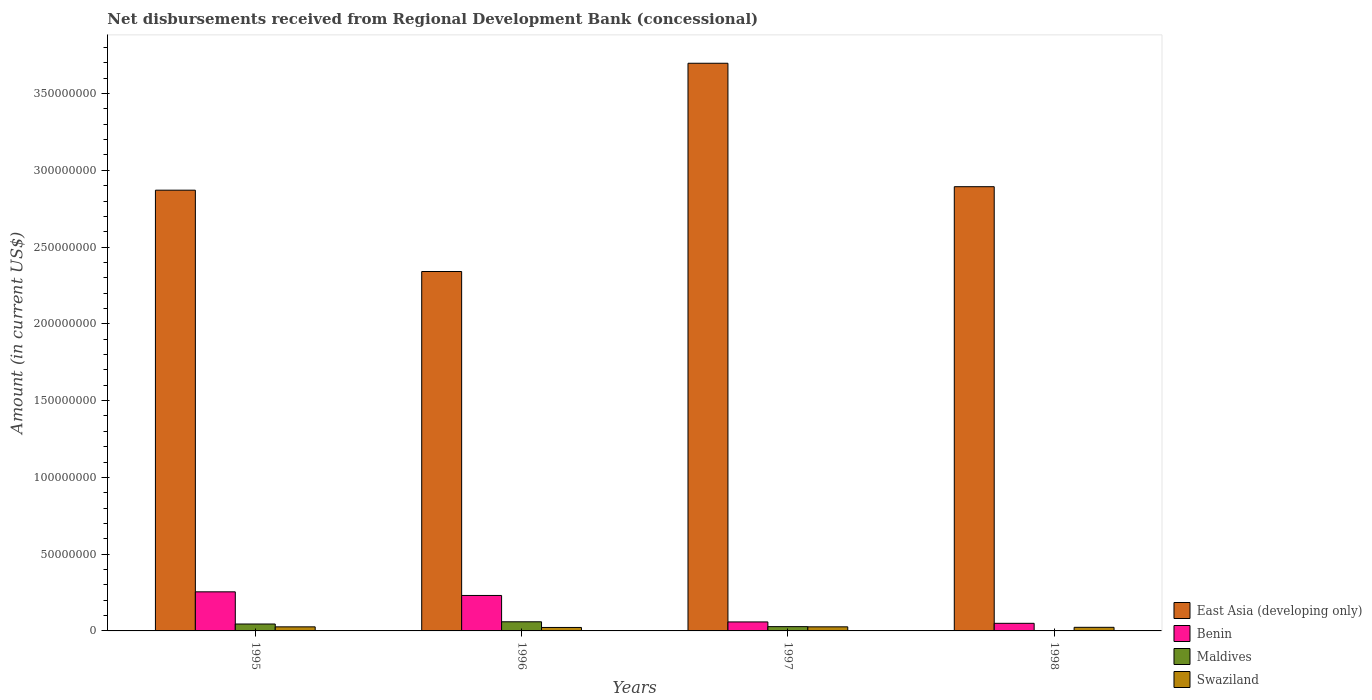How many different coloured bars are there?
Provide a succinct answer. 4. Are the number of bars on each tick of the X-axis equal?
Keep it short and to the point. Yes. How many bars are there on the 2nd tick from the left?
Your response must be concise. 4. How many bars are there on the 4th tick from the right?
Keep it short and to the point. 4. In how many cases, is the number of bars for a given year not equal to the number of legend labels?
Give a very brief answer. 0. What is the amount of disbursements received from Regional Development Bank in Swaziland in 1997?
Provide a succinct answer. 2.66e+06. Across all years, what is the maximum amount of disbursements received from Regional Development Bank in Swaziland?
Provide a succinct answer. 2.66e+06. Across all years, what is the minimum amount of disbursements received from Regional Development Bank in Swaziland?
Offer a very short reply. 2.25e+06. In which year was the amount of disbursements received from Regional Development Bank in East Asia (developing only) maximum?
Give a very brief answer. 1997. What is the total amount of disbursements received from Regional Development Bank in Maldives in the graph?
Make the answer very short. 1.35e+07. What is the difference between the amount of disbursements received from Regional Development Bank in Benin in 1995 and that in 1996?
Your response must be concise. 2.36e+06. What is the difference between the amount of disbursements received from Regional Development Bank in Benin in 1996 and the amount of disbursements received from Regional Development Bank in Swaziland in 1995?
Keep it short and to the point. 2.04e+07. What is the average amount of disbursements received from Regional Development Bank in Maldives per year?
Make the answer very short. 3.37e+06. In the year 1997, what is the difference between the amount of disbursements received from Regional Development Bank in Swaziland and amount of disbursements received from Regional Development Bank in Maldives?
Your answer should be compact. -1.33e+05. What is the ratio of the amount of disbursements received from Regional Development Bank in Swaziland in 1995 to that in 1996?
Offer a very short reply. 1.18. Is the amount of disbursements received from Regional Development Bank in Maldives in 1996 less than that in 1997?
Ensure brevity in your answer.  No. Is the difference between the amount of disbursements received from Regional Development Bank in Swaziland in 1996 and 1997 greater than the difference between the amount of disbursements received from Regional Development Bank in Maldives in 1996 and 1997?
Your answer should be very brief. No. What is the difference between the highest and the second highest amount of disbursements received from Regional Development Bank in Benin?
Provide a succinct answer. 2.36e+06. What is the difference between the highest and the lowest amount of disbursements received from Regional Development Bank in Benin?
Provide a succinct answer. 2.05e+07. In how many years, is the amount of disbursements received from Regional Development Bank in Benin greater than the average amount of disbursements received from Regional Development Bank in Benin taken over all years?
Offer a terse response. 2. Is it the case that in every year, the sum of the amount of disbursements received from Regional Development Bank in Maldives and amount of disbursements received from Regional Development Bank in East Asia (developing only) is greater than the sum of amount of disbursements received from Regional Development Bank in Swaziland and amount of disbursements received from Regional Development Bank in Benin?
Provide a succinct answer. Yes. What does the 2nd bar from the left in 1996 represents?
Offer a very short reply. Benin. What does the 3rd bar from the right in 1997 represents?
Provide a succinct answer. Benin. How many years are there in the graph?
Ensure brevity in your answer.  4. What is the difference between two consecutive major ticks on the Y-axis?
Offer a terse response. 5.00e+07. Are the values on the major ticks of Y-axis written in scientific E-notation?
Offer a terse response. No. Does the graph contain grids?
Give a very brief answer. No. What is the title of the graph?
Provide a succinct answer. Net disbursements received from Regional Development Bank (concessional). What is the Amount (in current US$) of East Asia (developing only) in 1995?
Your answer should be compact. 2.87e+08. What is the Amount (in current US$) of Benin in 1995?
Ensure brevity in your answer.  2.55e+07. What is the Amount (in current US$) in Maldives in 1995?
Ensure brevity in your answer.  4.51e+06. What is the Amount (in current US$) in Swaziland in 1995?
Offer a terse response. 2.65e+06. What is the Amount (in current US$) of East Asia (developing only) in 1996?
Provide a succinct answer. 2.34e+08. What is the Amount (in current US$) of Benin in 1996?
Provide a succinct answer. 2.31e+07. What is the Amount (in current US$) of Maldives in 1996?
Your answer should be very brief. 5.95e+06. What is the Amount (in current US$) in Swaziland in 1996?
Your response must be concise. 2.25e+06. What is the Amount (in current US$) in East Asia (developing only) in 1997?
Make the answer very short. 3.70e+08. What is the Amount (in current US$) of Benin in 1997?
Your answer should be compact. 5.86e+06. What is the Amount (in current US$) in Maldives in 1997?
Your answer should be compact. 2.80e+06. What is the Amount (in current US$) of Swaziland in 1997?
Offer a very short reply. 2.66e+06. What is the Amount (in current US$) of East Asia (developing only) in 1998?
Offer a terse response. 2.89e+08. What is the Amount (in current US$) in Benin in 1998?
Make the answer very short. 4.96e+06. What is the Amount (in current US$) of Maldives in 1998?
Your answer should be compact. 2.22e+05. What is the Amount (in current US$) of Swaziland in 1998?
Provide a succinct answer. 2.34e+06. Across all years, what is the maximum Amount (in current US$) in East Asia (developing only)?
Ensure brevity in your answer.  3.70e+08. Across all years, what is the maximum Amount (in current US$) in Benin?
Provide a succinct answer. 2.55e+07. Across all years, what is the maximum Amount (in current US$) in Maldives?
Provide a succinct answer. 5.95e+06. Across all years, what is the maximum Amount (in current US$) of Swaziland?
Offer a very short reply. 2.66e+06. Across all years, what is the minimum Amount (in current US$) of East Asia (developing only)?
Keep it short and to the point. 2.34e+08. Across all years, what is the minimum Amount (in current US$) in Benin?
Provide a succinct answer. 4.96e+06. Across all years, what is the minimum Amount (in current US$) of Maldives?
Offer a very short reply. 2.22e+05. Across all years, what is the minimum Amount (in current US$) of Swaziland?
Ensure brevity in your answer.  2.25e+06. What is the total Amount (in current US$) of East Asia (developing only) in the graph?
Make the answer very short. 1.18e+09. What is the total Amount (in current US$) in Benin in the graph?
Offer a very short reply. 5.94e+07. What is the total Amount (in current US$) in Maldives in the graph?
Your answer should be very brief. 1.35e+07. What is the total Amount (in current US$) in Swaziland in the graph?
Offer a very short reply. 9.91e+06. What is the difference between the Amount (in current US$) in East Asia (developing only) in 1995 and that in 1996?
Ensure brevity in your answer.  5.30e+07. What is the difference between the Amount (in current US$) in Benin in 1995 and that in 1996?
Make the answer very short. 2.36e+06. What is the difference between the Amount (in current US$) in Maldives in 1995 and that in 1996?
Your response must be concise. -1.44e+06. What is the difference between the Amount (in current US$) of Swaziland in 1995 and that in 1996?
Give a very brief answer. 3.98e+05. What is the difference between the Amount (in current US$) of East Asia (developing only) in 1995 and that in 1997?
Provide a short and direct response. -8.27e+07. What is the difference between the Amount (in current US$) in Benin in 1995 and that in 1997?
Offer a terse response. 1.96e+07. What is the difference between the Amount (in current US$) in Maldives in 1995 and that in 1997?
Provide a succinct answer. 1.71e+06. What is the difference between the Amount (in current US$) in Swaziland in 1995 and that in 1997?
Offer a very short reply. -1.20e+04. What is the difference between the Amount (in current US$) of East Asia (developing only) in 1995 and that in 1998?
Make the answer very short. -2.27e+06. What is the difference between the Amount (in current US$) in Benin in 1995 and that in 1998?
Your response must be concise. 2.05e+07. What is the difference between the Amount (in current US$) in Maldives in 1995 and that in 1998?
Ensure brevity in your answer.  4.29e+06. What is the difference between the Amount (in current US$) in Swaziland in 1995 and that in 1998?
Provide a short and direct response. 3.06e+05. What is the difference between the Amount (in current US$) in East Asia (developing only) in 1996 and that in 1997?
Provide a succinct answer. -1.36e+08. What is the difference between the Amount (in current US$) in Benin in 1996 and that in 1997?
Make the answer very short. 1.72e+07. What is the difference between the Amount (in current US$) in Maldives in 1996 and that in 1997?
Give a very brief answer. 3.15e+06. What is the difference between the Amount (in current US$) in Swaziland in 1996 and that in 1997?
Provide a succinct answer. -4.10e+05. What is the difference between the Amount (in current US$) in East Asia (developing only) in 1996 and that in 1998?
Offer a terse response. -5.53e+07. What is the difference between the Amount (in current US$) in Benin in 1996 and that in 1998?
Provide a short and direct response. 1.81e+07. What is the difference between the Amount (in current US$) of Maldives in 1996 and that in 1998?
Your response must be concise. 5.73e+06. What is the difference between the Amount (in current US$) of Swaziland in 1996 and that in 1998?
Offer a terse response. -9.20e+04. What is the difference between the Amount (in current US$) of East Asia (developing only) in 1997 and that in 1998?
Provide a succinct answer. 8.04e+07. What is the difference between the Amount (in current US$) of Benin in 1997 and that in 1998?
Provide a short and direct response. 9.02e+05. What is the difference between the Amount (in current US$) of Maldives in 1997 and that in 1998?
Provide a succinct answer. 2.57e+06. What is the difference between the Amount (in current US$) of Swaziland in 1997 and that in 1998?
Your answer should be compact. 3.18e+05. What is the difference between the Amount (in current US$) in East Asia (developing only) in 1995 and the Amount (in current US$) in Benin in 1996?
Your answer should be compact. 2.64e+08. What is the difference between the Amount (in current US$) in East Asia (developing only) in 1995 and the Amount (in current US$) in Maldives in 1996?
Your answer should be very brief. 2.81e+08. What is the difference between the Amount (in current US$) of East Asia (developing only) in 1995 and the Amount (in current US$) of Swaziland in 1996?
Provide a short and direct response. 2.85e+08. What is the difference between the Amount (in current US$) of Benin in 1995 and the Amount (in current US$) of Maldives in 1996?
Keep it short and to the point. 1.95e+07. What is the difference between the Amount (in current US$) in Benin in 1995 and the Amount (in current US$) in Swaziland in 1996?
Keep it short and to the point. 2.32e+07. What is the difference between the Amount (in current US$) of Maldives in 1995 and the Amount (in current US$) of Swaziland in 1996?
Your answer should be compact. 2.26e+06. What is the difference between the Amount (in current US$) of East Asia (developing only) in 1995 and the Amount (in current US$) of Benin in 1997?
Keep it short and to the point. 2.81e+08. What is the difference between the Amount (in current US$) in East Asia (developing only) in 1995 and the Amount (in current US$) in Maldives in 1997?
Your response must be concise. 2.84e+08. What is the difference between the Amount (in current US$) of East Asia (developing only) in 1995 and the Amount (in current US$) of Swaziland in 1997?
Give a very brief answer. 2.84e+08. What is the difference between the Amount (in current US$) in Benin in 1995 and the Amount (in current US$) in Maldives in 1997?
Your response must be concise. 2.27e+07. What is the difference between the Amount (in current US$) in Benin in 1995 and the Amount (in current US$) in Swaziland in 1997?
Offer a very short reply. 2.28e+07. What is the difference between the Amount (in current US$) in Maldives in 1995 and the Amount (in current US$) in Swaziland in 1997?
Make the answer very short. 1.85e+06. What is the difference between the Amount (in current US$) in East Asia (developing only) in 1995 and the Amount (in current US$) in Benin in 1998?
Offer a very short reply. 2.82e+08. What is the difference between the Amount (in current US$) in East Asia (developing only) in 1995 and the Amount (in current US$) in Maldives in 1998?
Provide a short and direct response. 2.87e+08. What is the difference between the Amount (in current US$) in East Asia (developing only) in 1995 and the Amount (in current US$) in Swaziland in 1998?
Provide a succinct answer. 2.85e+08. What is the difference between the Amount (in current US$) of Benin in 1995 and the Amount (in current US$) of Maldives in 1998?
Your answer should be compact. 2.52e+07. What is the difference between the Amount (in current US$) of Benin in 1995 and the Amount (in current US$) of Swaziland in 1998?
Ensure brevity in your answer.  2.31e+07. What is the difference between the Amount (in current US$) in Maldives in 1995 and the Amount (in current US$) in Swaziland in 1998?
Make the answer very short. 2.16e+06. What is the difference between the Amount (in current US$) in East Asia (developing only) in 1996 and the Amount (in current US$) in Benin in 1997?
Ensure brevity in your answer.  2.28e+08. What is the difference between the Amount (in current US$) in East Asia (developing only) in 1996 and the Amount (in current US$) in Maldives in 1997?
Your answer should be compact. 2.31e+08. What is the difference between the Amount (in current US$) in East Asia (developing only) in 1996 and the Amount (in current US$) in Swaziland in 1997?
Give a very brief answer. 2.31e+08. What is the difference between the Amount (in current US$) of Benin in 1996 and the Amount (in current US$) of Maldives in 1997?
Provide a succinct answer. 2.03e+07. What is the difference between the Amount (in current US$) in Benin in 1996 and the Amount (in current US$) in Swaziland in 1997?
Your answer should be very brief. 2.04e+07. What is the difference between the Amount (in current US$) of Maldives in 1996 and the Amount (in current US$) of Swaziland in 1997?
Offer a very short reply. 3.29e+06. What is the difference between the Amount (in current US$) in East Asia (developing only) in 1996 and the Amount (in current US$) in Benin in 1998?
Provide a succinct answer. 2.29e+08. What is the difference between the Amount (in current US$) of East Asia (developing only) in 1996 and the Amount (in current US$) of Maldives in 1998?
Offer a terse response. 2.34e+08. What is the difference between the Amount (in current US$) in East Asia (developing only) in 1996 and the Amount (in current US$) in Swaziland in 1998?
Keep it short and to the point. 2.32e+08. What is the difference between the Amount (in current US$) of Benin in 1996 and the Amount (in current US$) of Maldives in 1998?
Ensure brevity in your answer.  2.29e+07. What is the difference between the Amount (in current US$) in Benin in 1996 and the Amount (in current US$) in Swaziland in 1998?
Offer a terse response. 2.08e+07. What is the difference between the Amount (in current US$) of Maldives in 1996 and the Amount (in current US$) of Swaziland in 1998?
Give a very brief answer. 3.60e+06. What is the difference between the Amount (in current US$) in East Asia (developing only) in 1997 and the Amount (in current US$) in Benin in 1998?
Make the answer very short. 3.65e+08. What is the difference between the Amount (in current US$) of East Asia (developing only) in 1997 and the Amount (in current US$) of Maldives in 1998?
Provide a succinct answer. 3.70e+08. What is the difference between the Amount (in current US$) of East Asia (developing only) in 1997 and the Amount (in current US$) of Swaziland in 1998?
Keep it short and to the point. 3.67e+08. What is the difference between the Amount (in current US$) in Benin in 1997 and the Amount (in current US$) in Maldives in 1998?
Offer a very short reply. 5.64e+06. What is the difference between the Amount (in current US$) of Benin in 1997 and the Amount (in current US$) of Swaziland in 1998?
Your answer should be very brief. 3.51e+06. What is the difference between the Amount (in current US$) of Maldives in 1997 and the Amount (in current US$) of Swaziland in 1998?
Your response must be concise. 4.51e+05. What is the average Amount (in current US$) of East Asia (developing only) per year?
Provide a short and direct response. 2.95e+08. What is the average Amount (in current US$) of Benin per year?
Offer a very short reply. 1.48e+07. What is the average Amount (in current US$) of Maldives per year?
Make the answer very short. 3.37e+06. What is the average Amount (in current US$) in Swaziland per year?
Keep it short and to the point. 2.48e+06. In the year 1995, what is the difference between the Amount (in current US$) in East Asia (developing only) and Amount (in current US$) in Benin?
Ensure brevity in your answer.  2.62e+08. In the year 1995, what is the difference between the Amount (in current US$) in East Asia (developing only) and Amount (in current US$) in Maldives?
Your answer should be very brief. 2.83e+08. In the year 1995, what is the difference between the Amount (in current US$) in East Asia (developing only) and Amount (in current US$) in Swaziland?
Your answer should be compact. 2.84e+08. In the year 1995, what is the difference between the Amount (in current US$) of Benin and Amount (in current US$) of Maldives?
Provide a short and direct response. 2.09e+07. In the year 1995, what is the difference between the Amount (in current US$) of Benin and Amount (in current US$) of Swaziland?
Make the answer very short. 2.28e+07. In the year 1995, what is the difference between the Amount (in current US$) in Maldives and Amount (in current US$) in Swaziland?
Your answer should be compact. 1.86e+06. In the year 1996, what is the difference between the Amount (in current US$) of East Asia (developing only) and Amount (in current US$) of Benin?
Give a very brief answer. 2.11e+08. In the year 1996, what is the difference between the Amount (in current US$) in East Asia (developing only) and Amount (in current US$) in Maldives?
Offer a terse response. 2.28e+08. In the year 1996, what is the difference between the Amount (in current US$) of East Asia (developing only) and Amount (in current US$) of Swaziland?
Offer a terse response. 2.32e+08. In the year 1996, what is the difference between the Amount (in current US$) of Benin and Amount (in current US$) of Maldives?
Keep it short and to the point. 1.72e+07. In the year 1996, what is the difference between the Amount (in current US$) in Benin and Amount (in current US$) in Swaziland?
Your answer should be compact. 2.08e+07. In the year 1996, what is the difference between the Amount (in current US$) in Maldives and Amount (in current US$) in Swaziland?
Provide a short and direct response. 3.70e+06. In the year 1997, what is the difference between the Amount (in current US$) in East Asia (developing only) and Amount (in current US$) in Benin?
Give a very brief answer. 3.64e+08. In the year 1997, what is the difference between the Amount (in current US$) in East Asia (developing only) and Amount (in current US$) in Maldives?
Your answer should be compact. 3.67e+08. In the year 1997, what is the difference between the Amount (in current US$) in East Asia (developing only) and Amount (in current US$) in Swaziland?
Your answer should be compact. 3.67e+08. In the year 1997, what is the difference between the Amount (in current US$) of Benin and Amount (in current US$) of Maldives?
Offer a terse response. 3.06e+06. In the year 1997, what is the difference between the Amount (in current US$) of Benin and Amount (in current US$) of Swaziland?
Your response must be concise. 3.20e+06. In the year 1997, what is the difference between the Amount (in current US$) in Maldives and Amount (in current US$) in Swaziland?
Ensure brevity in your answer.  1.33e+05. In the year 1998, what is the difference between the Amount (in current US$) of East Asia (developing only) and Amount (in current US$) of Benin?
Offer a very short reply. 2.84e+08. In the year 1998, what is the difference between the Amount (in current US$) of East Asia (developing only) and Amount (in current US$) of Maldives?
Offer a terse response. 2.89e+08. In the year 1998, what is the difference between the Amount (in current US$) in East Asia (developing only) and Amount (in current US$) in Swaziland?
Offer a very short reply. 2.87e+08. In the year 1998, what is the difference between the Amount (in current US$) of Benin and Amount (in current US$) of Maldives?
Your answer should be very brief. 4.73e+06. In the year 1998, what is the difference between the Amount (in current US$) in Benin and Amount (in current US$) in Swaziland?
Make the answer very short. 2.61e+06. In the year 1998, what is the difference between the Amount (in current US$) of Maldives and Amount (in current US$) of Swaziland?
Provide a short and direct response. -2.12e+06. What is the ratio of the Amount (in current US$) of East Asia (developing only) in 1995 to that in 1996?
Offer a terse response. 1.23. What is the ratio of the Amount (in current US$) of Benin in 1995 to that in 1996?
Offer a very short reply. 1.1. What is the ratio of the Amount (in current US$) of Maldives in 1995 to that in 1996?
Your response must be concise. 0.76. What is the ratio of the Amount (in current US$) in Swaziland in 1995 to that in 1996?
Keep it short and to the point. 1.18. What is the ratio of the Amount (in current US$) of East Asia (developing only) in 1995 to that in 1997?
Offer a terse response. 0.78. What is the ratio of the Amount (in current US$) of Benin in 1995 to that in 1997?
Your response must be concise. 4.35. What is the ratio of the Amount (in current US$) of Maldives in 1995 to that in 1997?
Keep it short and to the point. 1.61. What is the ratio of the Amount (in current US$) in East Asia (developing only) in 1995 to that in 1998?
Provide a short and direct response. 0.99. What is the ratio of the Amount (in current US$) of Benin in 1995 to that in 1998?
Ensure brevity in your answer.  5.14. What is the ratio of the Amount (in current US$) of Maldives in 1995 to that in 1998?
Offer a very short reply. 20.31. What is the ratio of the Amount (in current US$) in Swaziland in 1995 to that in 1998?
Provide a succinct answer. 1.13. What is the ratio of the Amount (in current US$) of East Asia (developing only) in 1996 to that in 1997?
Give a very brief answer. 0.63. What is the ratio of the Amount (in current US$) in Benin in 1996 to that in 1997?
Ensure brevity in your answer.  3.94. What is the ratio of the Amount (in current US$) in Maldives in 1996 to that in 1997?
Your response must be concise. 2.13. What is the ratio of the Amount (in current US$) in Swaziland in 1996 to that in 1997?
Ensure brevity in your answer.  0.85. What is the ratio of the Amount (in current US$) in East Asia (developing only) in 1996 to that in 1998?
Keep it short and to the point. 0.81. What is the ratio of the Amount (in current US$) of Benin in 1996 to that in 1998?
Provide a short and direct response. 4.66. What is the ratio of the Amount (in current US$) of Maldives in 1996 to that in 1998?
Make the answer very short. 26.79. What is the ratio of the Amount (in current US$) in Swaziland in 1996 to that in 1998?
Keep it short and to the point. 0.96. What is the ratio of the Amount (in current US$) of East Asia (developing only) in 1997 to that in 1998?
Provide a short and direct response. 1.28. What is the ratio of the Amount (in current US$) in Benin in 1997 to that in 1998?
Provide a succinct answer. 1.18. What is the ratio of the Amount (in current US$) in Maldives in 1997 to that in 1998?
Your answer should be compact. 12.59. What is the ratio of the Amount (in current US$) of Swaziland in 1997 to that in 1998?
Provide a short and direct response. 1.14. What is the difference between the highest and the second highest Amount (in current US$) of East Asia (developing only)?
Offer a very short reply. 8.04e+07. What is the difference between the highest and the second highest Amount (in current US$) in Benin?
Keep it short and to the point. 2.36e+06. What is the difference between the highest and the second highest Amount (in current US$) in Maldives?
Keep it short and to the point. 1.44e+06. What is the difference between the highest and the second highest Amount (in current US$) of Swaziland?
Your response must be concise. 1.20e+04. What is the difference between the highest and the lowest Amount (in current US$) of East Asia (developing only)?
Give a very brief answer. 1.36e+08. What is the difference between the highest and the lowest Amount (in current US$) of Benin?
Your response must be concise. 2.05e+07. What is the difference between the highest and the lowest Amount (in current US$) of Maldives?
Your response must be concise. 5.73e+06. 